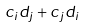<formula> <loc_0><loc_0><loc_500><loc_500>c _ { i } d _ { j } + c _ { j } d _ { i }</formula> 